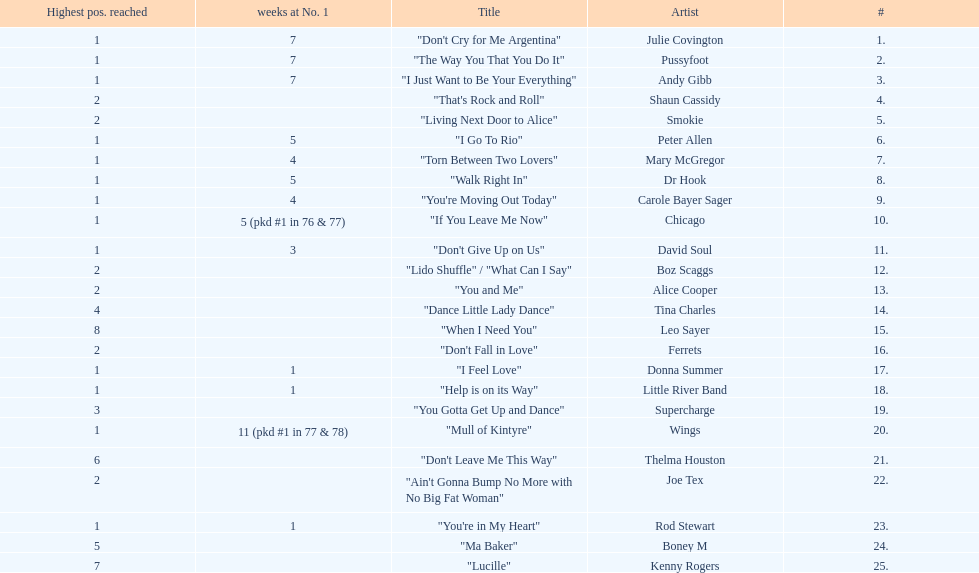What was the number of weeks that julie covington's single " don't cry for me argentinia," was at number 1 in 1977? 7. 